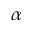Convert formula to latex. <formula><loc_0><loc_0><loc_500><loc_500>\alpha</formula> 